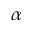Convert formula to latex. <formula><loc_0><loc_0><loc_500><loc_500>\alpha</formula> 